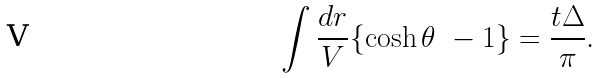<formula> <loc_0><loc_0><loc_500><loc_500>\int \frac { d r } { V } \{ \cosh \theta \ - 1 \} = \frac { t \Delta } { \pi } .</formula> 